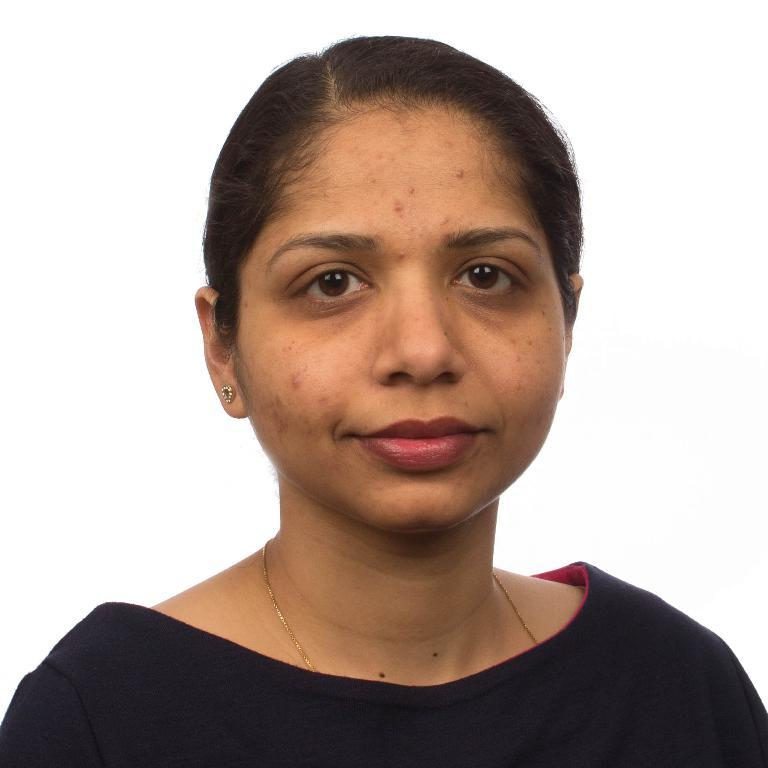Who is present in the image? There is a woman in the image. What is the woman wearing? The woman is wearing a black dress. What expression does the woman have? The woman is smiling. What is the color of the background in the image? The background of the image is white. What type of soup is the woman holding in the image? There is no soup present in the image; the woman is not holding anything. Can you describe the creature that is interacting with the woman in the image? There is no creature present in the image; the woman is alone. 